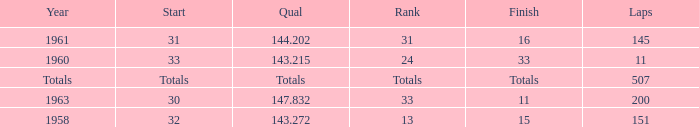What's the Finish rank of 31? 16.0. 